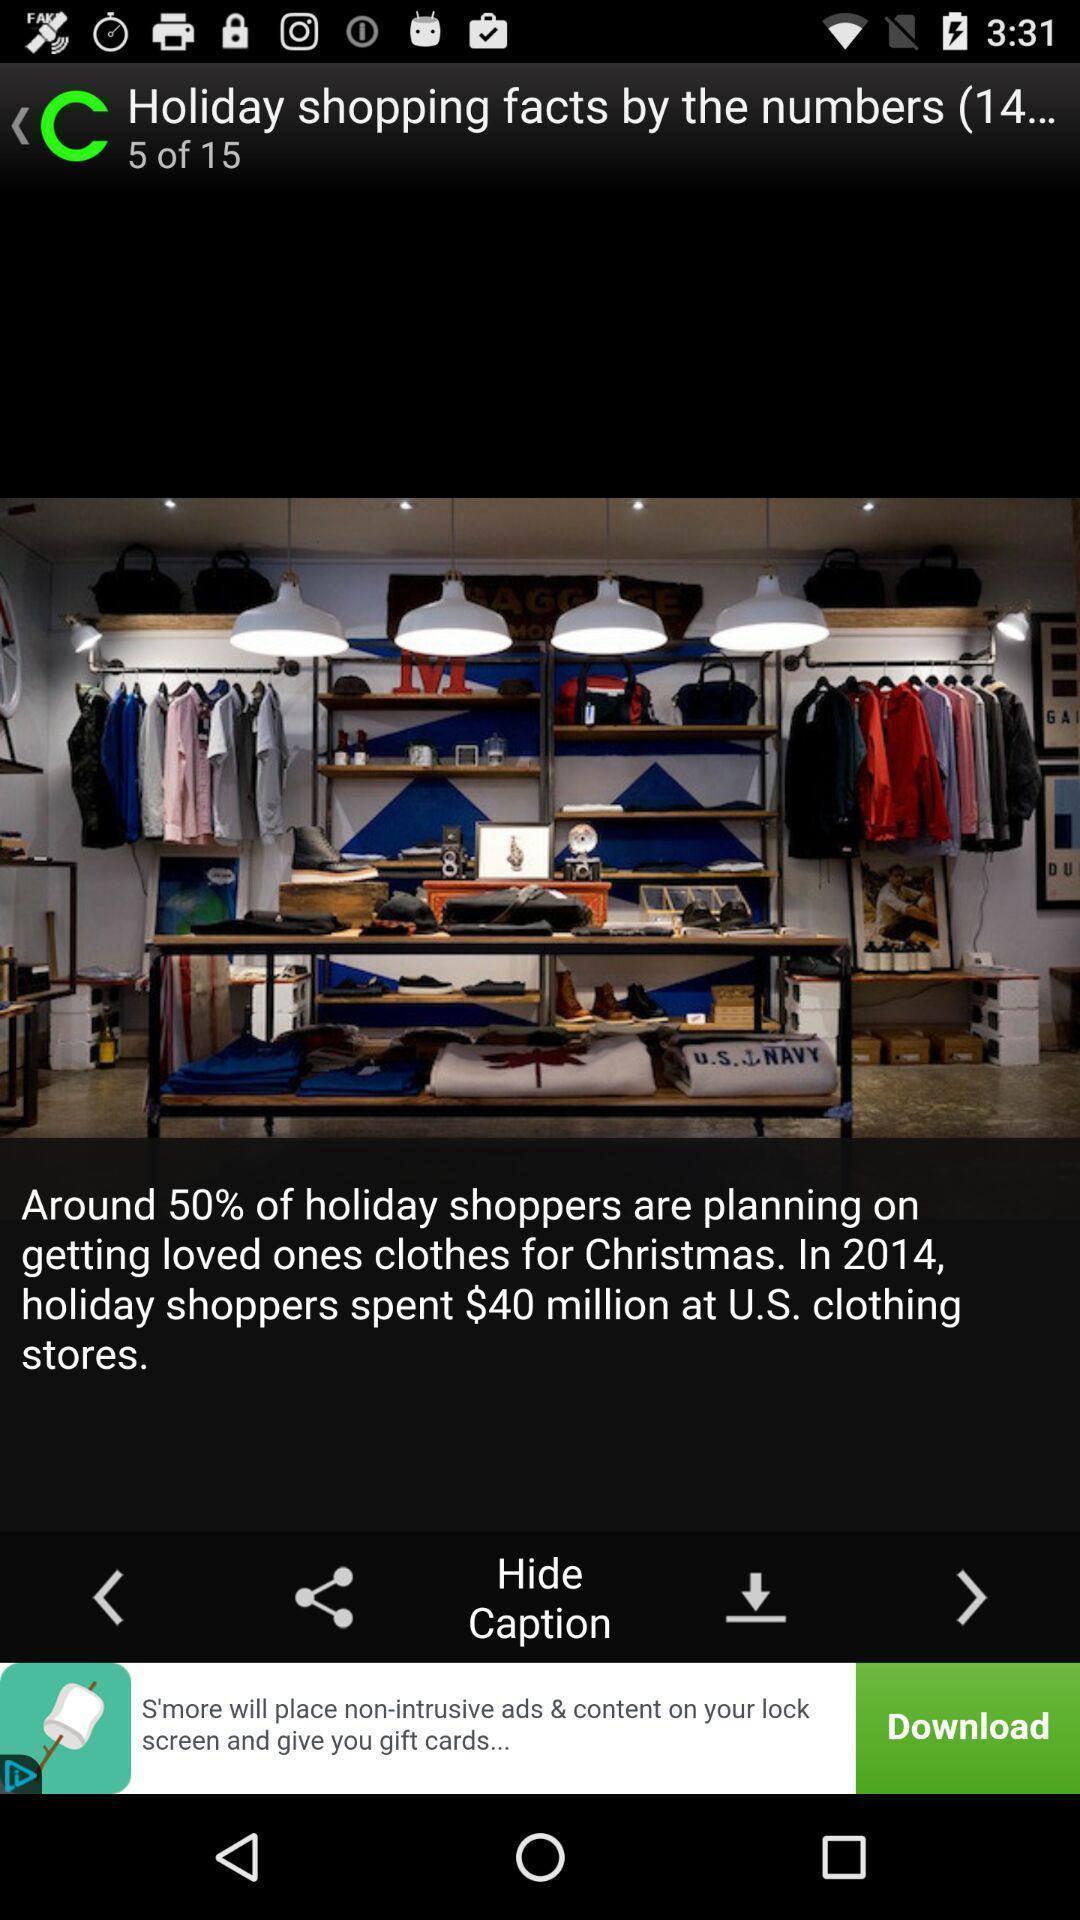Describe the visual elements of this screenshot. Page displays clothing store in app. 